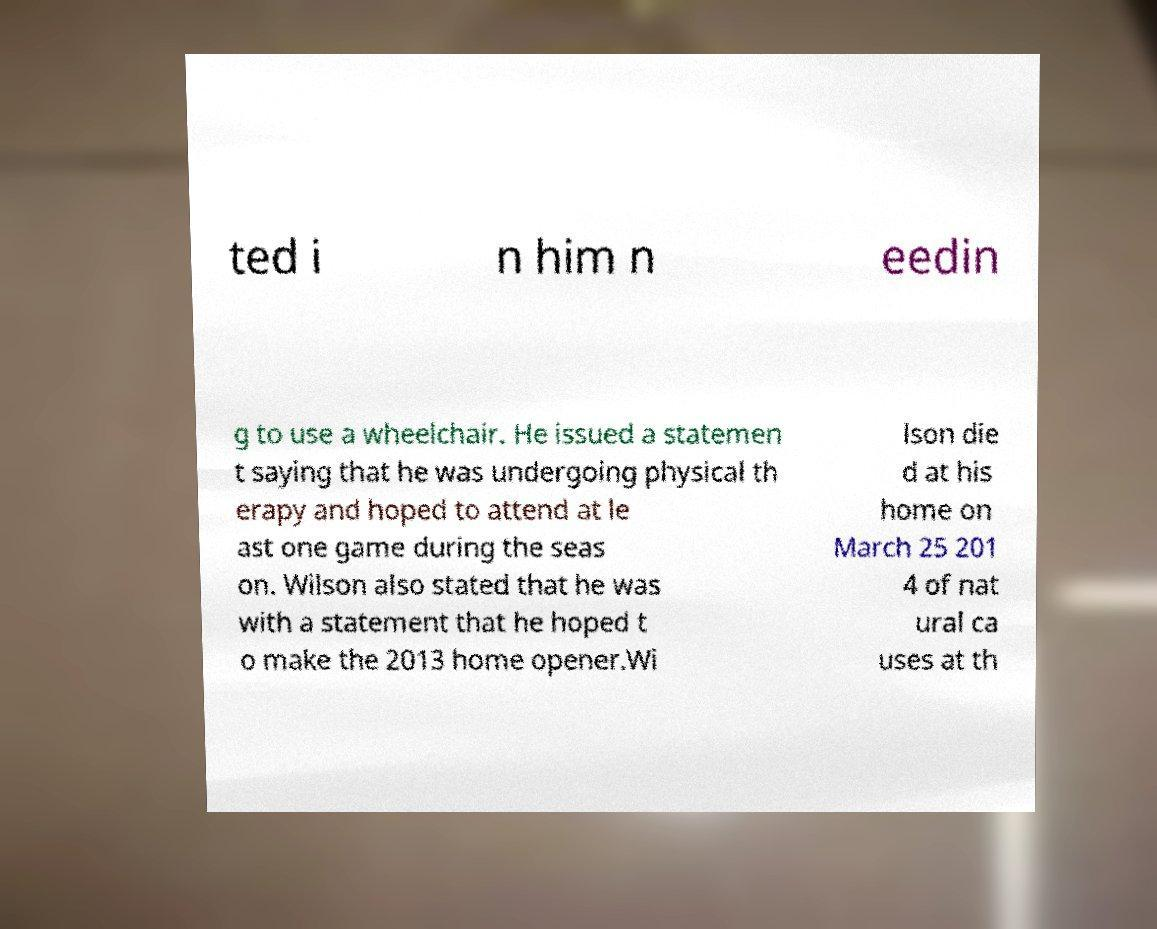For documentation purposes, I need the text within this image transcribed. Could you provide that? ted i n him n eedin g to use a wheelchair. He issued a statemen t saying that he was undergoing physical th erapy and hoped to attend at le ast one game during the seas on. Wilson also stated that he was with a statement that he hoped t o make the 2013 home opener.Wi lson die d at his home on March 25 201 4 of nat ural ca uses at th 